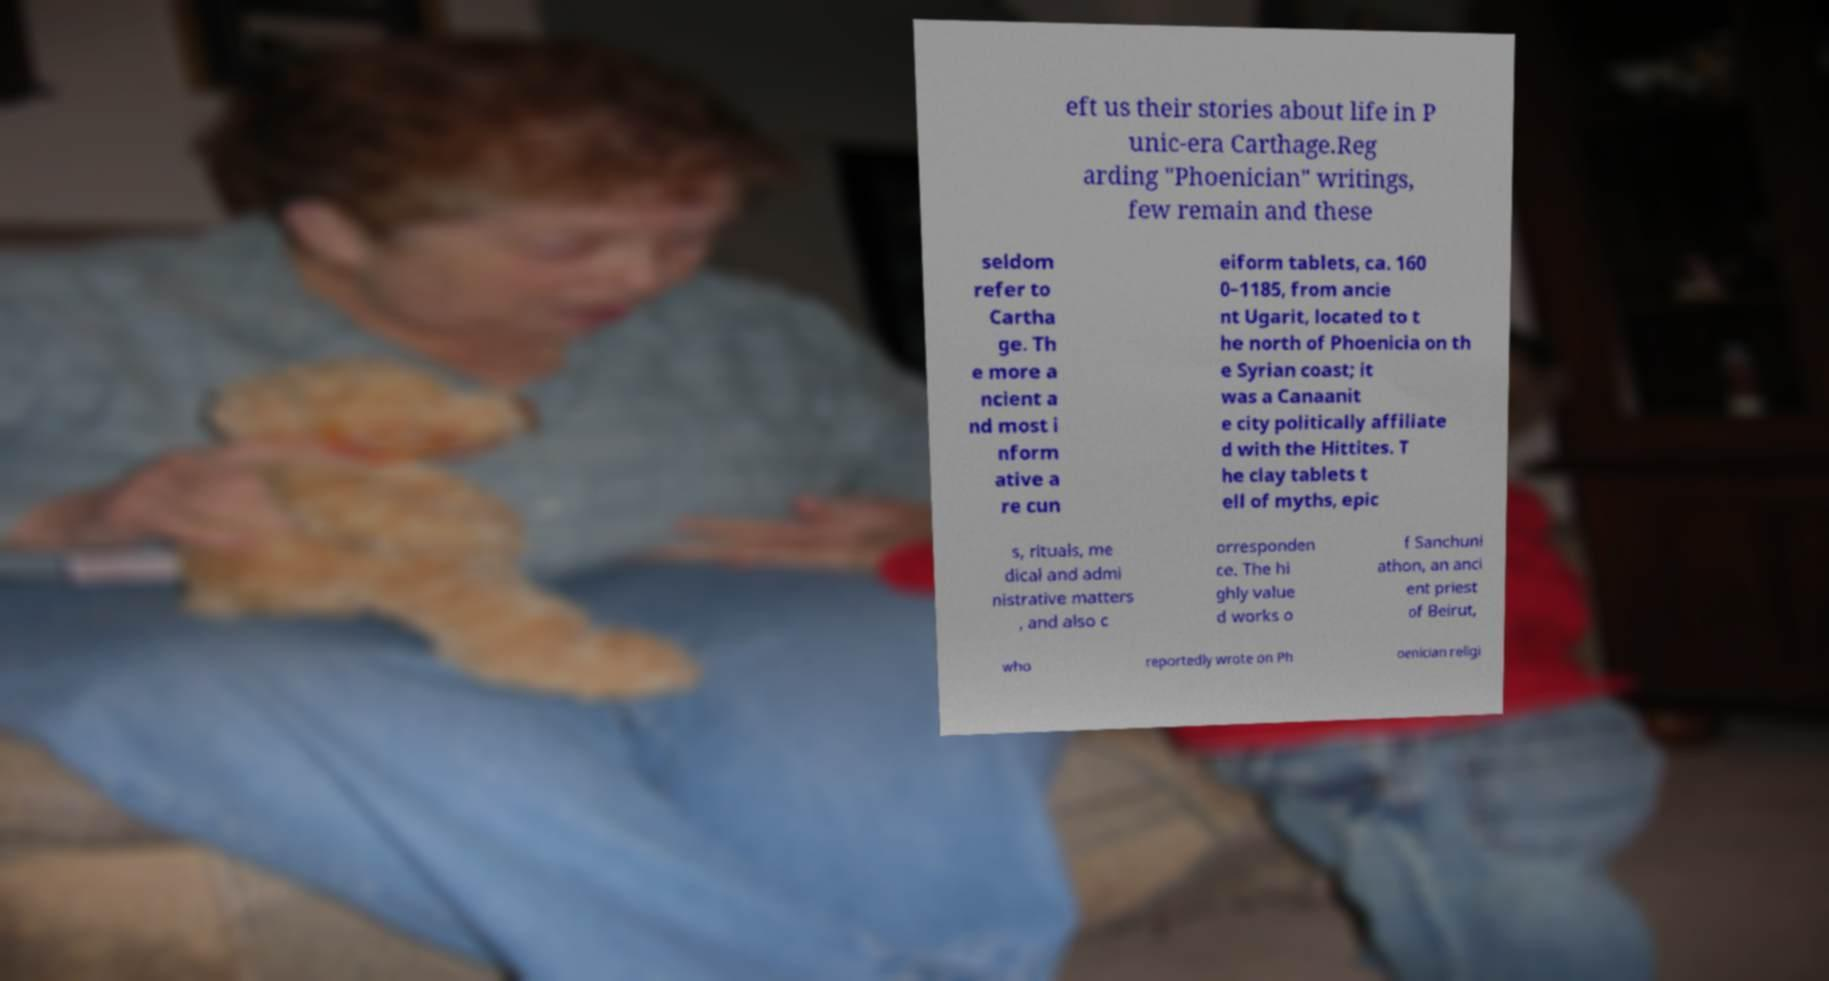There's text embedded in this image that I need extracted. Can you transcribe it verbatim? eft us their stories about life in P unic-era Carthage.Reg arding "Phoenician" writings, few remain and these seldom refer to Cartha ge. Th e more a ncient a nd most i nform ative a re cun eiform tablets, ca. 160 0–1185, from ancie nt Ugarit, located to t he north of Phoenicia on th e Syrian coast; it was a Canaanit e city politically affiliate d with the Hittites. T he clay tablets t ell of myths, epic s, rituals, me dical and admi nistrative matters , and also c orresponden ce. The hi ghly value d works o f Sanchuni athon, an anci ent priest of Beirut, who reportedly wrote on Ph oenician religi 